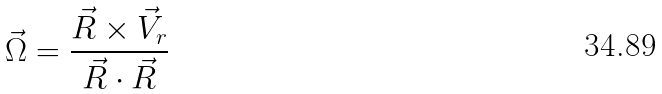Convert formula to latex. <formula><loc_0><loc_0><loc_500><loc_500>\vec { \Omega } = \frac { \vec { R } \times \vec { V } _ { r } } { \vec { R } \cdot \vec { R } }</formula> 